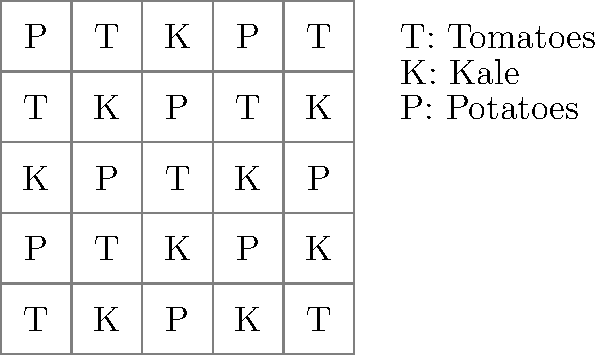You are planning your countryside garden using a $5 \times 5$ grid, where each cell represents a plot for a specific crop. The grid shows an arrangement of Tomatoes (T), Kale (K), and Potatoes (P). To maximize yield and soil health, you want to ensure that no two adjacent plots (horizontally or vertically) contain the same crop. How many violations of this rule are there in the current arrangement? To solve this problem, we need to check each pair of adjacent plots (horizontally and vertically) and count the number of violations. Let's go through this step-by-step:

1) First, check horizontal adjacencies:
   Row 1: No violations
   Row 2: 1 violation (K-K between columns 4 and 5)
   Row 3: 1 violation (K-K between columns 3 and 4)
   Row 4: No violations
   Row 5: No violations
   Horizontal violations: 2

2) Now, check vertical adjacencies:
   Column 1: 1 violation (T-T between rows 1 and 4)
   Column 2: 1 violation (K-K between rows 1 and 2)
   Column 3: 1 violation (P-P between rows 2 and 3)
   Column 4: 1 violation (K-K between rows 2 and 3)
   Column 5: 1 violation (T-T between rows 4 and 5)
   Vertical violations: 5

3) Sum up the total violations:
   Total violations = Horizontal violations + Vertical violations
                    = 2 + 5 = 7

Therefore, there are 7 violations of the rule in the current arrangement.
Answer: 7 violations 